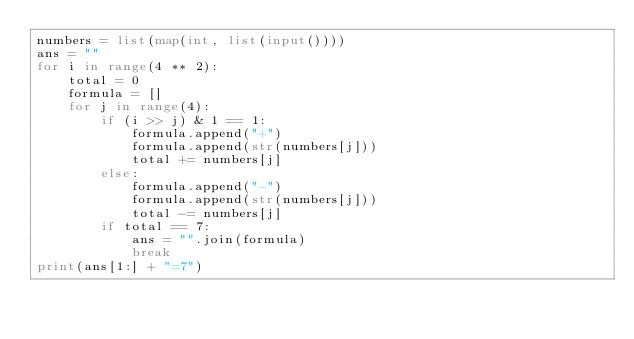<code> <loc_0><loc_0><loc_500><loc_500><_Python_>numbers = list(map(int, list(input())))
ans = ""
for i in range(4 ** 2):
    total = 0
    formula = []
    for j in range(4):
        if (i >> j) & 1 == 1:
            formula.append("+")
            formula.append(str(numbers[j]))
            total += numbers[j]
        else:
            formula.append("-")
            formula.append(str(numbers[j]))
            total -= numbers[j]
        if total == 7:
            ans = "".join(formula)
            break
print(ans[1:] + "=7")
</code> 